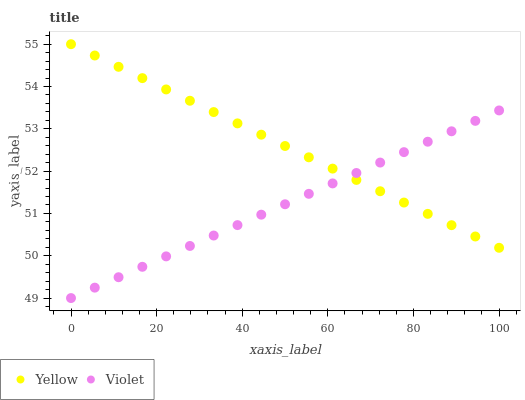Does Violet have the minimum area under the curve?
Answer yes or no. Yes. Does Yellow have the maximum area under the curve?
Answer yes or no. Yes. Does Violet have the maximum area under the curve?
Answer yes or no. No. Is Yellow the smoothest?
Answer yes or no. Yes. Is Violet the roughest?
Answer yes or no. Yes. Is Violet the smoothest?
Answer yes or no. No. Does Violet have the lowest value?
Answer yes or no. Yes. Does Yellow have the highest value?
Answer yes or no. Yes. Does Violet have the highest value?
Answer yes or no. No. Does Violet intersect Yellow?
Answer yes or no. Yes. Is Violet less than Yellow?
Answer yes or no. No. Is Violet greater than Yellow?
Answer yes or no. No. 